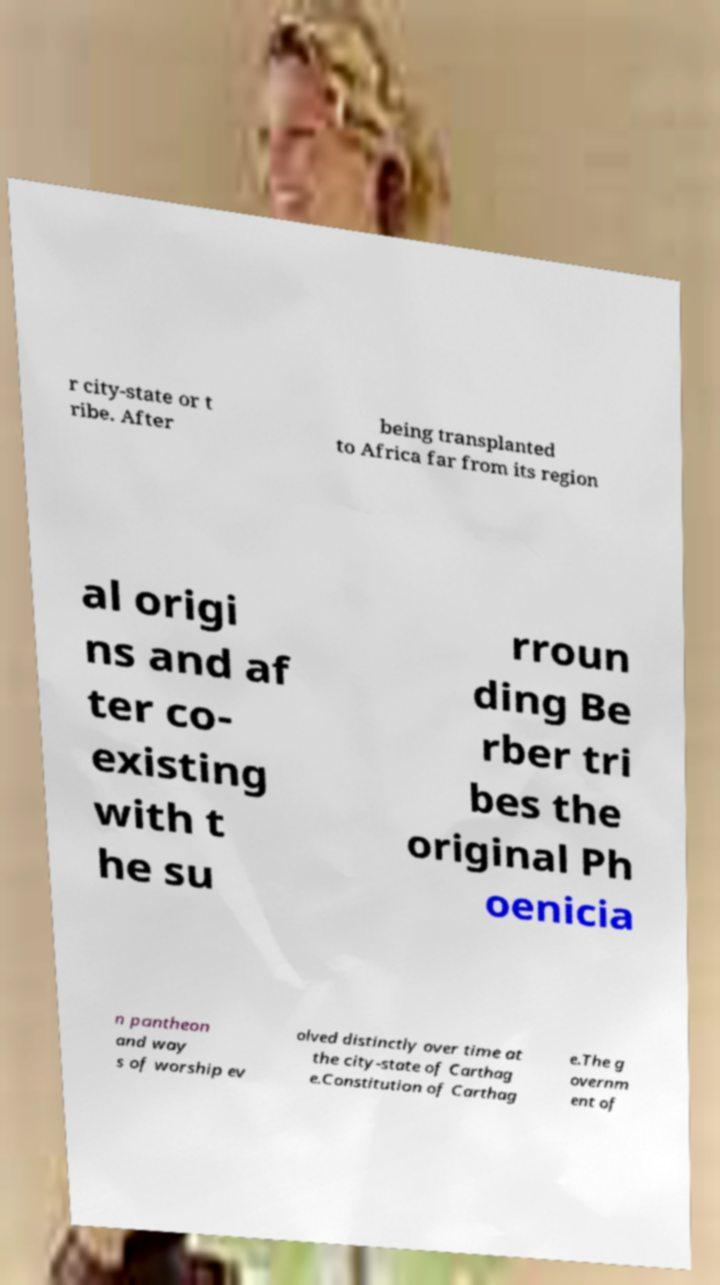Could you extract and type out the text from this image? r city-state or t ribe. After being transplanted to Africa far from its region al origi ns and af ter co- existing with t he su rroun ding Be rber tri bes the original Ph oenicia n pantheon and way s of worship ev olved distinctly over time at the city-state of Carthag e.Constitution of Carthag e.The g overnm ent of 